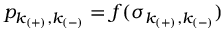<formula> <loc_0><loc_0><loc_500><loc_500>p _ { k _ { ( + ) } , k _ { ( - ) } } = f ( \sigma _ { k _ { ( + ) } , k _ { ( - ) } } )</formula> 